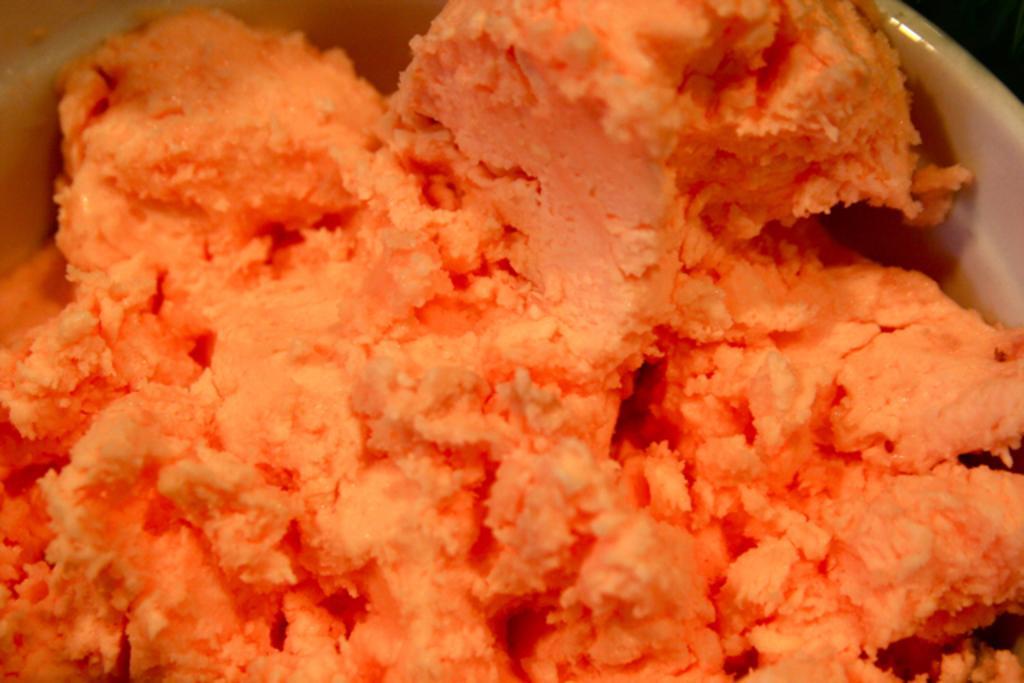Could you give a brief overview of what you see in this image? In this image there is a bowl having ice cream. 